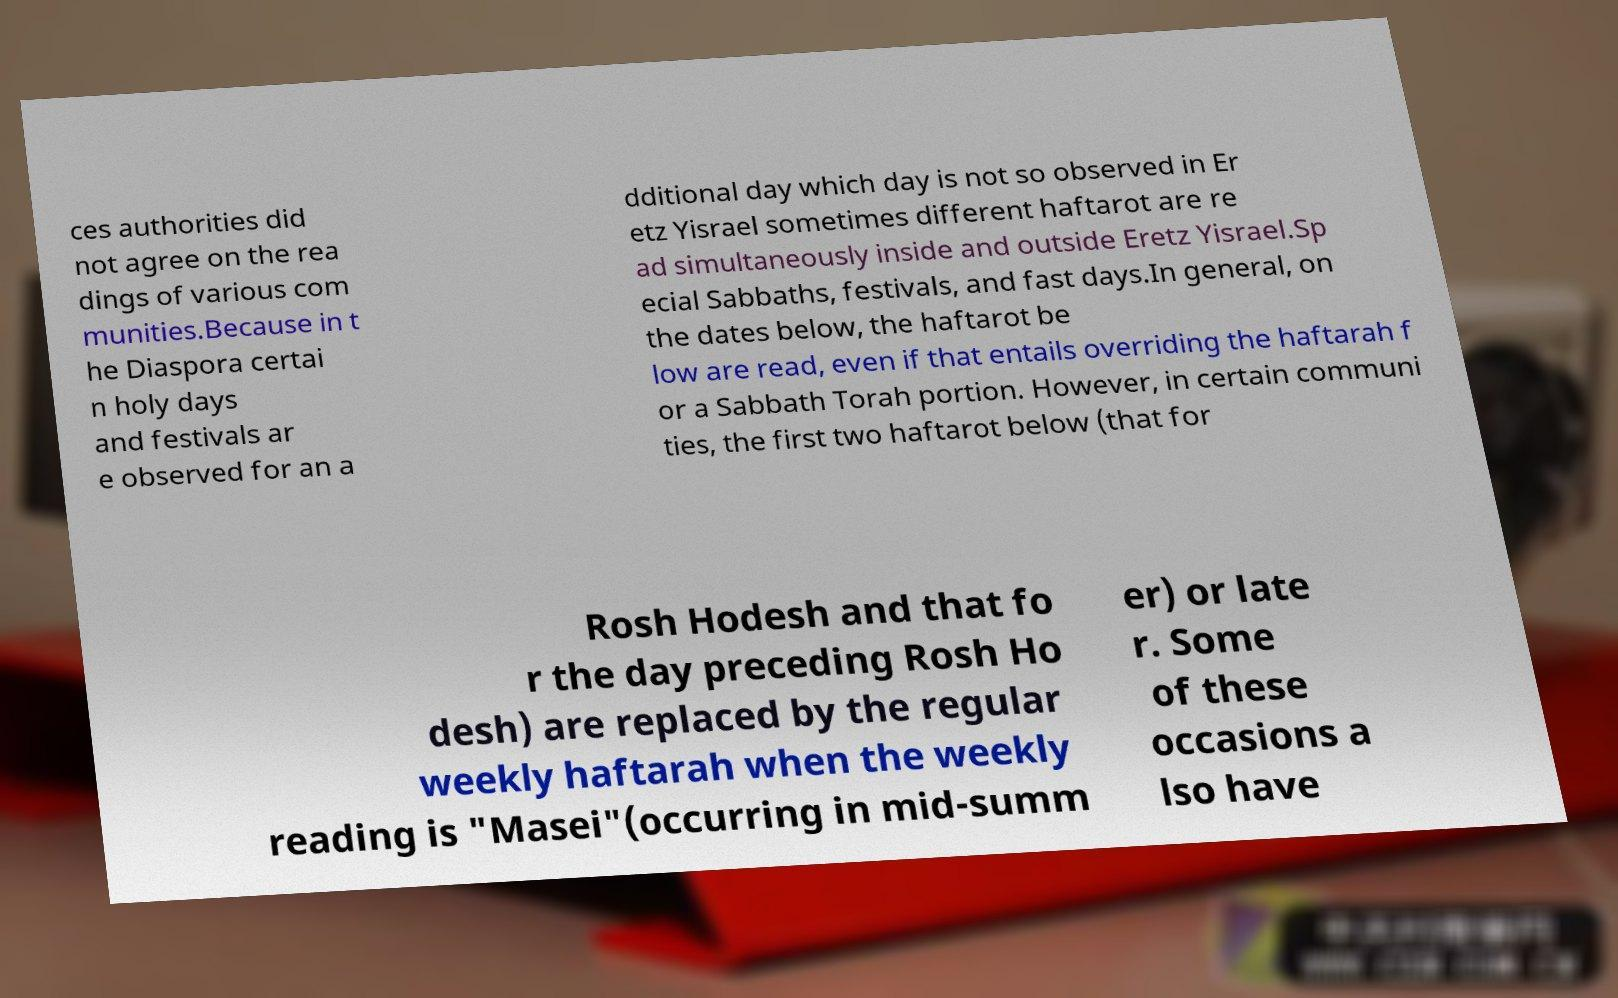Could you assist in decoding the text presented in this image and type it out clearly? ces authorities did not agree on the rea dings of various com munities.Because in t he Diaspora certai n holy days and festivals ar e observed for an a dditional day which day is not so observed in Er etz Yisrael sometimes different haftarot are re ad simultaneously inside and outside Eretz Yisrael.Sp ecial Sabbaths, festivals, and fast days.In general, on the dates below, the haftarot be low are read, even if that entails overriding the haftarah f or a Sabbath Torah portion. However, in certain communi ties, the first two haftarot below (that for Rosh Hodesh and that fo r the day preceding Rosh Ho desh) are replaced by the regular weekly haftarah when the weekly reading is "Masei"(occurring in mid-summ er) or late r. Some of these occasions a lso have 